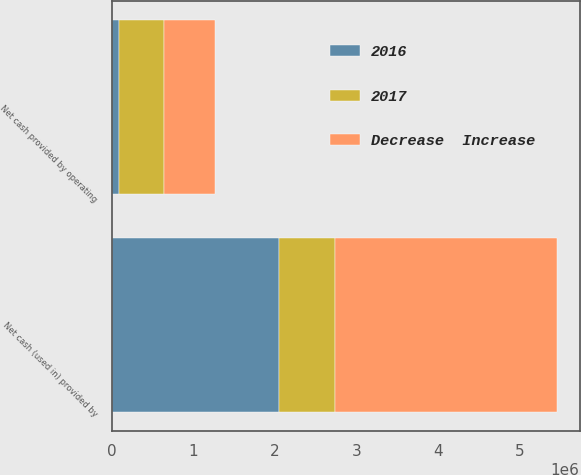Convert chart. <chart><loc_0><loc_0><loc_500><loc_500><stacked_bar_chart><ecel><fcel>Net cash provided by operating<fcel>Net cash (used in) provided by<nl><fcel>2017<fcel>548373<fcel>681077<nl><fcel>Decrease  Increase<fcel>634714<fcel>2.73324e+06<nl><fcel>2016<fcel>86341<fcel>2.05216e+06<nl></chart> 